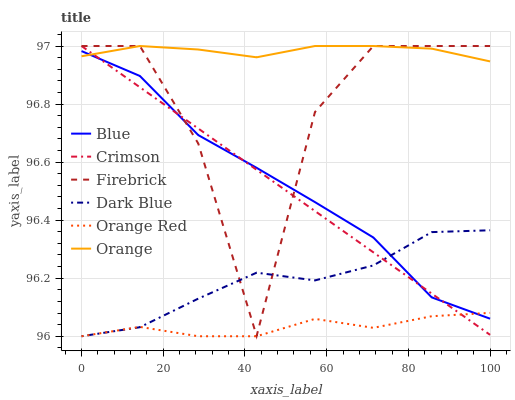Does Orange Red have the minimum area under the curve?
Answer yes or no. Yes. Does Orange have the maximum area under the curve?
Answer yes or no. Yes. Does Dark Blue have the minimum area under the curve?
Answer yes or no. No. Does Dark Blue have the maximum area under the curve?
Answer yes or no. No. Is Crimson the smoothest?
Answer yes or no. Yes. Is Firebrick the roughest?
Answer yes or no. Yes. Is Dark Blue the smoothest?
Answer yes or no. No. Is Dark Blue the roughest?
Answer yes or no. No. Does Dark Blue have the lowest value?
Answer yes or no. Yes. Does Firebrick have the lowest value?
Answer yes or no. No. Does Crimson have the highest value?
Answer yes or no. Yes. Does Dark Blue have the highest value?
Answer yes or no. No. Is Orange Red less than Orange?
Answer yes or no. Yes. Is Orange greater than Dark Blue?
Answer yes or no. Yes. Does Dark Blue intersect Firebrick?
Answer yes or no. Yes. Is Dark Blue less than Firebrick?
Answer yes or no. No. Is Dark Blue greater than Firebrick?
Answer yes or no. No. Does Orange Red intersect Orange?
Answer yes or no. No. 